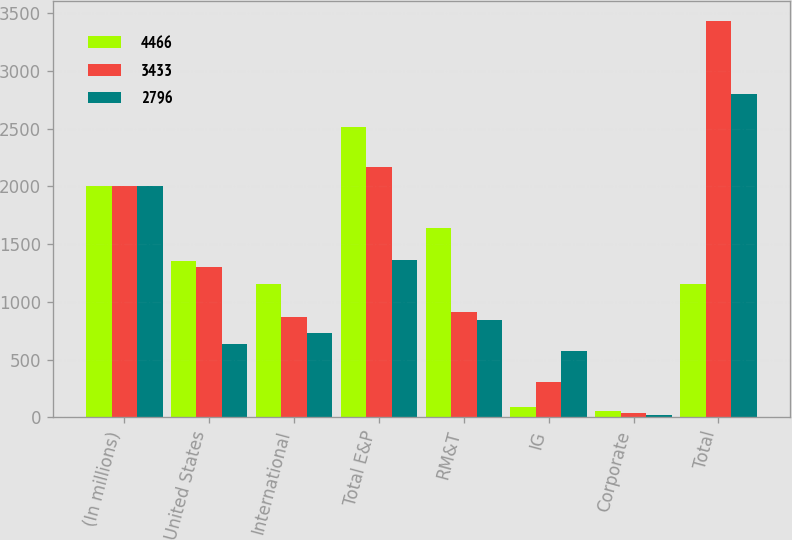Convert chart to OTSL. <chart><loc_0><loc_0><loc_500><loc_500><stacked_bar_chart><ecel><fcel>(In millions)<fcel>United States<fcel>International<fcel>Total E&P<fcel>RM&T<fcel>IG<fcel>Corporate<fcel>Total<nl><fcel>4466<fcel>2007<fcel>1354<fcel>1157<fcel>2511<fcel>1640<fcel>93<fcel>57<fcel>1157<nl><fcel>3433<fcel>2006<fcel>1302<fcel>867<fcel>2169<fcel>916<fcel>307<fcel>41<fcel>3433<nl><fcel>2796<fcel>2005<fcel>638<fcel>728<fcel>1366<fcel>841<fcel>571<fcel>18<fcel>2796<nl></chart> 